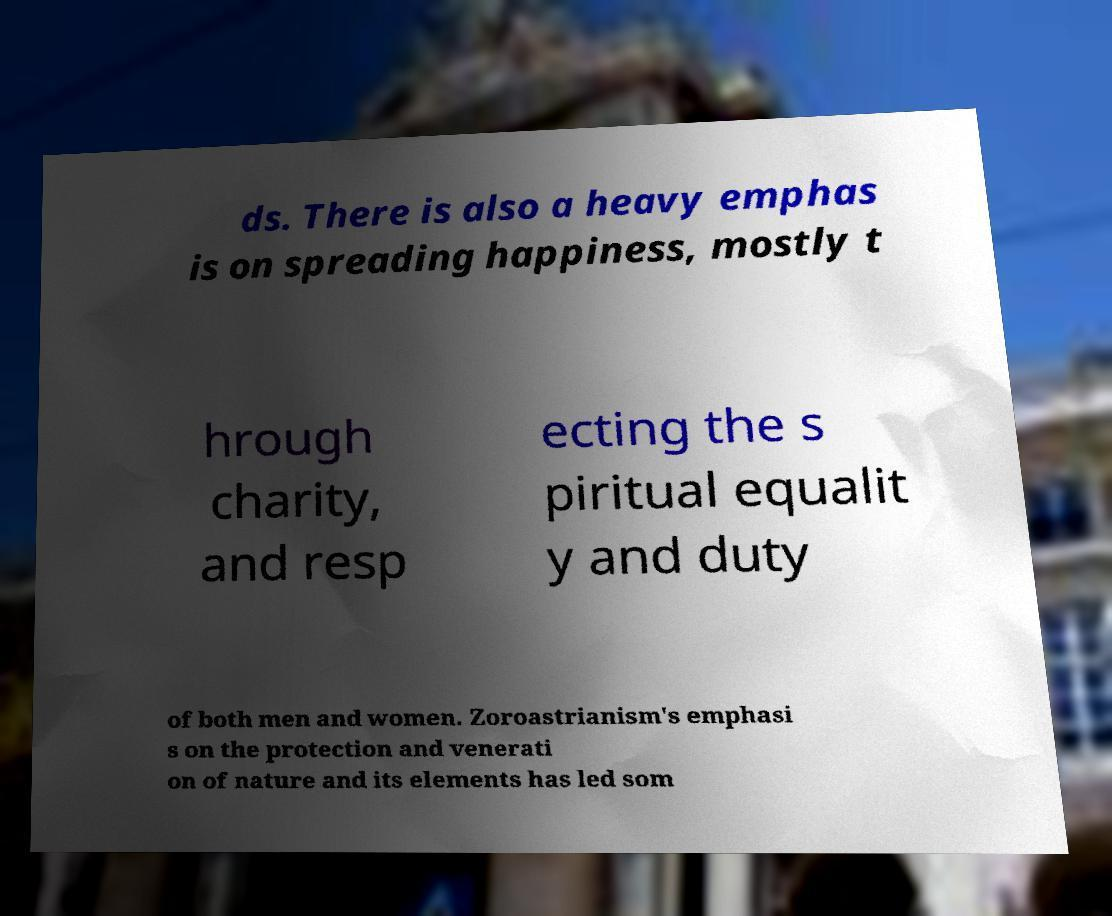Could you assist in decoding the text presented in this image and type it out clearly? ds. There is also a heavy emphas is on spreading happiness, mostly t hrough charity, and resp ecting the s piritual equalit y and duty of both men and women. Zoroastrianism's emphasi s on the protection and venerati on of nature and its elements has led som 